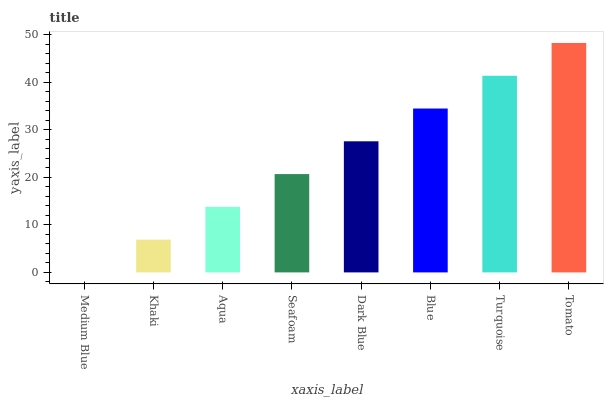Is Medium Blue the minimum?
Answer yes or no. Yes. Is Tomato the maximum?
Answer yes or no. Yes. Is Khaki the minimum?
Answer yes or no. No. Is Khaki the maximum?
Answer yes or no. No. Is Khaki greater than Medium Blue?
Answer yes or no. Yes. Is Medium Blue less than Khaki?
Answer yes or no. Yes. Is Medium Blue greater than Khaki?
Answer yes or no. No. Is Khaki less than Medium Blue?
Answer yes or no. No. Is Dark Blue the high median?
Answer yes or no. Yes. Is Seafoam the low median?
Answer yes or no. Yes. Is Turquoise the high median?
Answer yes or no. No. Is Dark Blue the low median?
Answer yes or no. No. 